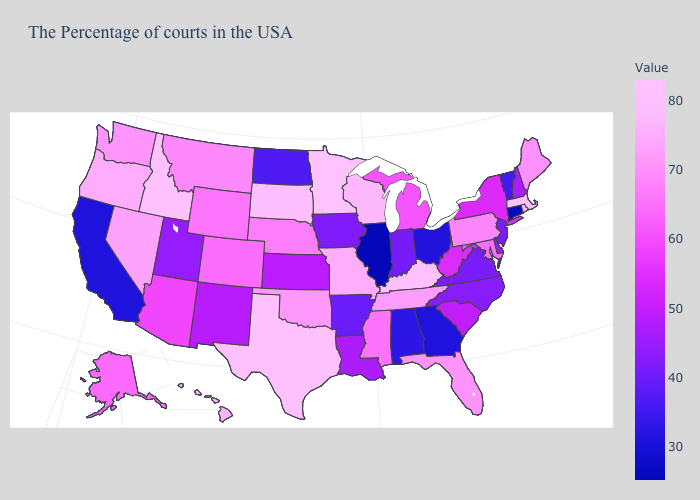Does Illinois have the lowest value in the USA?
Short answer required. Yes. Among the states that border Michigan , which have the lowest value?
Concise answer only. Ohio. Does New Hampshire have the highest value in the Northeast?
Give a very brief answer. No. Does North Dakota have the lowest value in the MidWest?
Quick response, please. No. Among the states that border Wisconsin , which have the lowest value?
Write a very short answer. Illinois. Which states have the lowest value in the West?
Concise answer only. California. 